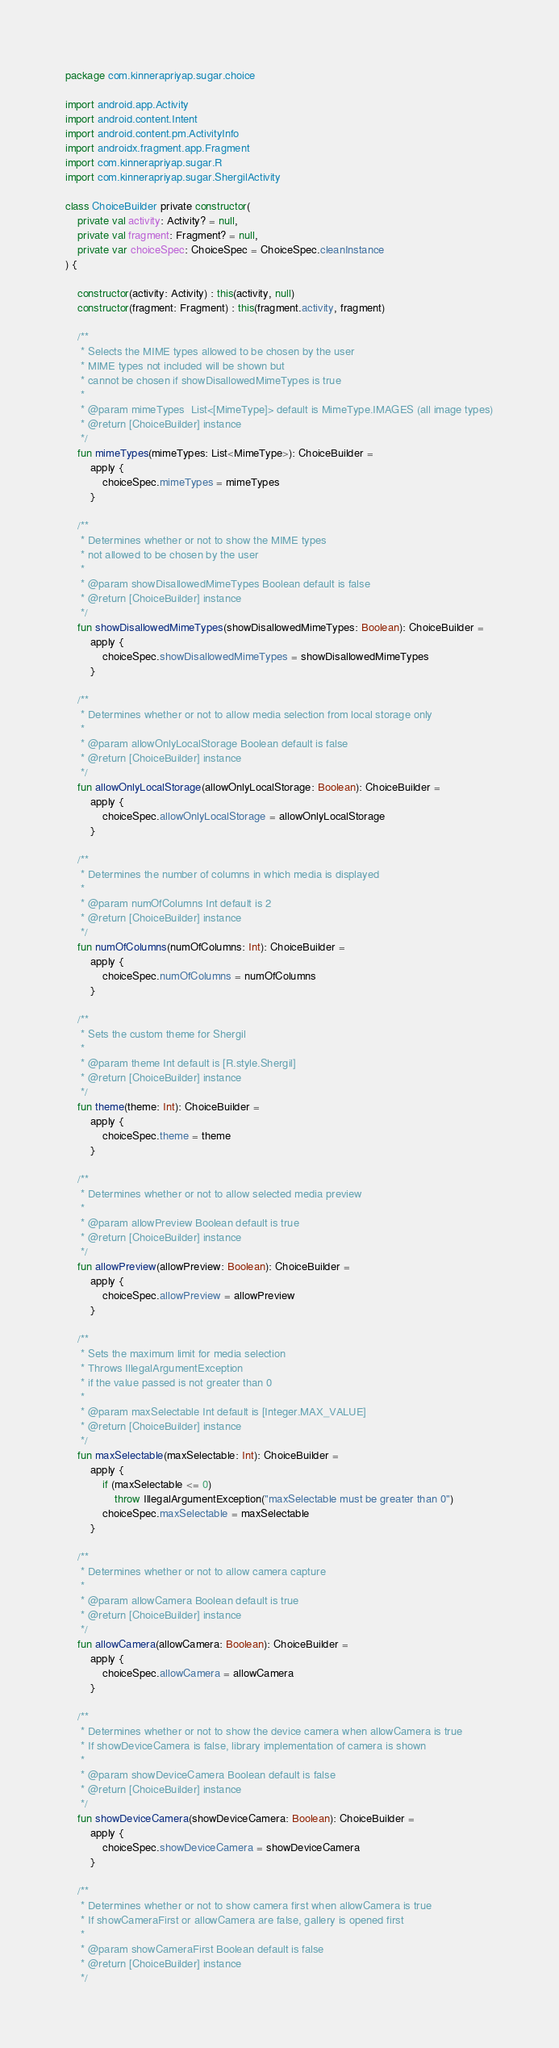<code> <loc_0><loc_0><loc_500><loc_500><_Kotlin_>package com.kinnerapriyap.sugar.choice

import android.app.Activity
import android.content.Intent
import android.content.pm.ActivityInfo
import androidx.fragment.app.Fragment
import com.kinnerapriyap.sugar.R
import com.kinnerapriyap.sugar.ShergilActivity

class ChoiceBuilder private constructor(
    private val activity: Activity? = null,
    private val fragment: Fragment? = null,
    private var choiceSpec: ChoiceSpec = ChoiceSpec.cleanInstance
) {

    constructor(activity: Activity) : this(activity, null)
    constructor(fragment: Fragment) : this(fragment.activity, fragment)

    /**
     * Selects the MIME types allowed to be chosen by the user
     * MIME types not included will be shown but
     * cannot be chosen if showDisallowedMimeTypes is true
     *
     * @param mimeTypes  List<[MimeType]> default is MimeType.IMAGES (all image types)
     * @return [ChoiceBuilder] instance
     */
    fun mimeTypes(mimeTypes: List<MimeType>): ChoiceBuilder =
        apply {
            choiceSpec.mimeTypes = mimeTypes
        }

    /**
     * Determines whether or not to show the MIME types
     * not allowed to be chosen by the user
     *
     * @param showDisallowedMimeTypes Boolean default is false
     * @return [ChoiceBuilder] instance
     */
    fun showDisallowedMimeTypes(showDisallowedMimeTypes: Boolean): ChoiceBuilder =
        apply {
            choiceSpec.showDisallowedMimeTypes = showDisallowedMimeTypes
        }

    /**
     * Determines whether or not to allow media selection from local storage only
     *
     * @param allowOnlyLocalStorage Boolean default is false
     * @return [ChoiceBuilder] instance
     */
    fun allowOnlyLocalStorage(allowOnlyLocalStorage: Boolean): ChoiceBuilder =
        apply {
            choiceSpec.allowOnlyLocalStorage = allowOnlyLocalStorage
        }

    /**
     * Determines the number of columns in which media is displayed
     *
     * @param numOfColumns Int default is 2
     * @return [ChoiceBuilder] instance
     */
    fun numOfColumns(numOfColumns: Int): ChoiceBuilder =
        apply {
            choiceSpec.numOfColumns = numOfColumns
        }

    /**
     * Sets the custom theme for Shergil
     *
     * @param theme Int default is [R.style.Shergil]
     * @return [ChoiceBuilder] instance
     */
    fun theme(theme: Int): ChoiceBuilder =
        apply {
            choiceSpec.theme = theme
        }

    /**
     * Determines whether or not to allow selected media preview
     *
     * @param allowPreview Boolean default is true
     * @return [ChoiceBuilder] instance
     */
    fun allowPreview(allowPreview: Boolean): ChoiceBuilder =
        apply {
            choiceSpec.allowPreview = allowPreview
        }

    /**
     * Sets the maximum limit for media selection
     * Throws IllegalArgumentException
     * if the value passed is not greater than 0
     *
     * @param maxSelectable Int default is [Integer.MAX_VALUE]
     * @return [ChoiceBuilder] instance
     */
    fun maxSelectable(maxSelectable: Int): ChoiceBuilder =
        apply {
            if (maxSelectable <= 0)
                throw IllegalArgumentException("maxSelectable must be greater than 0")
            choiceSpec.maxSelectable = maxSelectable
        }

    /**
     * Determines whether or not to allow camera capture
     *
     * @param allowCamera Boolean default is true
     * @return [ChoiceBuilder] instance
     */
    fun allowCamera(allowCamera: Boolean): ChoiceBuilder =
        apply {
            choiceSpec.allowCamera = allowCamera
        }

    /**
     * Determines whether or not to show the device camera when allowCamera is true
     * If showDeviceCamera is false, library implementation of camera is shown
     *
     * @param showDeviceCamera Boolean default is false
     * @return [ChoiceBuilder] instance
     */
    fun showDeviceCamera(showDeviceCamera: Boolean): ChoiceBuilder =
        apply {
            choiceSpec.showDeviceCamera = showDeviceCamera
        }

    /**
     * Determines whether or not to show camera first when allowCamera is true
     * If showCameraFirst or allowCamera are false, gallery is opened first
     *
     * @param showCameraFirst Boolean default is false
     * @return [ChoiceBuilder] instance
     */</code> 